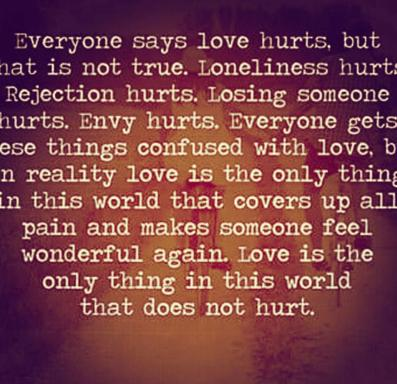What are some of the negative emotions mentioned in the image? The image poignantly lists negative emotions like loneliness, rejection, losing someone, and envy. These are often mistaken for the essence of love, suggesting a profound misunderstanding of its true nature. 